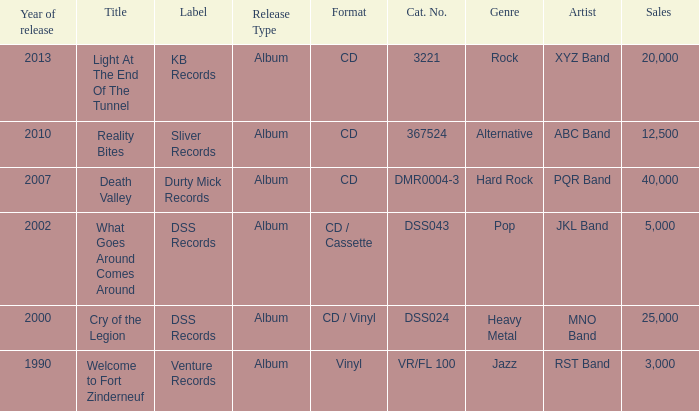What is the latest year of the album with the release title death valley? 2007.0. 